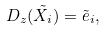Convert formula to latex. <formula><loc_0><loc_0><loc_500><loc_500>D _ { z } ( \tilde { X } _ { i } ) = \tilde { e } _ { i } ,</formula> 